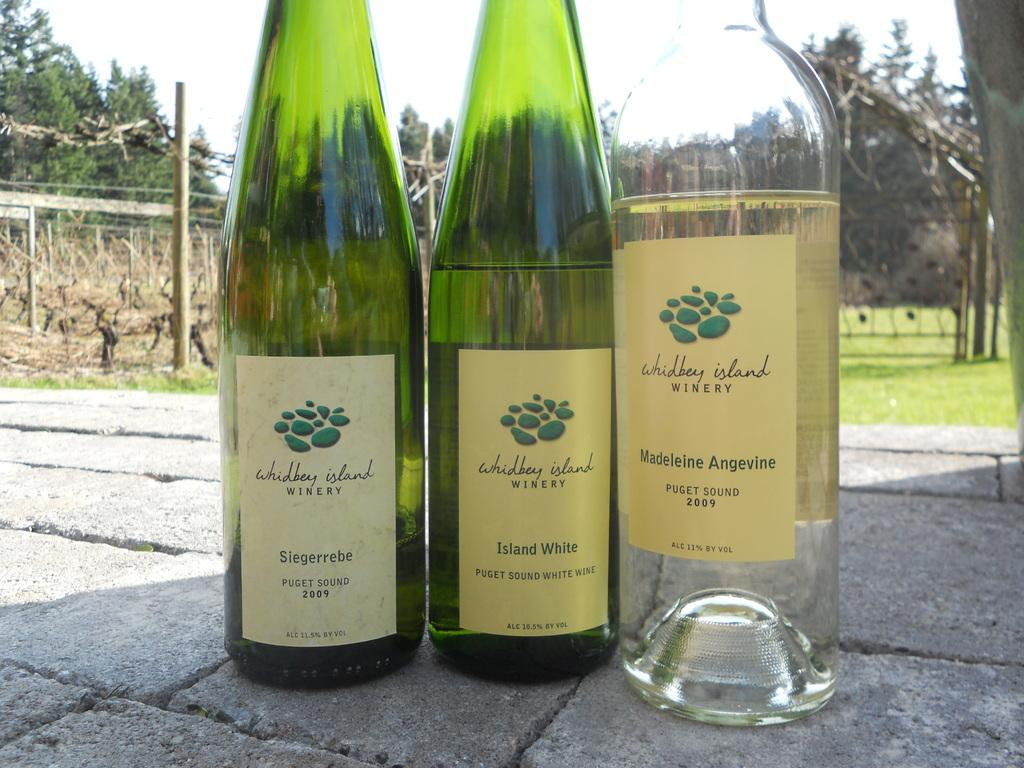How many wine bottles are present in the image? There are three wine bottles in the image. What can be seen in the background of the image? There are directories in the backdrop of the image. What is the condition of the sky in the image? The sky is clear in the image. What type of vegetation is visible in the image? There is grass visible in the image. What is the purpose of the waste in the image? There is no waste present in the image, so it is not possible to determine its purpose. 